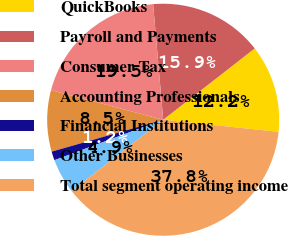<chart> <loc_0><loc_0><loc_500><loc_500><pie_chart><fcel>QuickBooks<fcel>Payroll and Payments<fcel>Consumer Tax<fcel>Accounting Professionals<fcel>Financial Institutions<fcel>Other Businesses<fcel>Total segment operating income<nl><fcel>12.2%<fcel>15.85%<fcel>19.51%<fcel>8.54%<fcel>1.23%<fcel>4.88%<fcel>37.79%<nl></chart> 